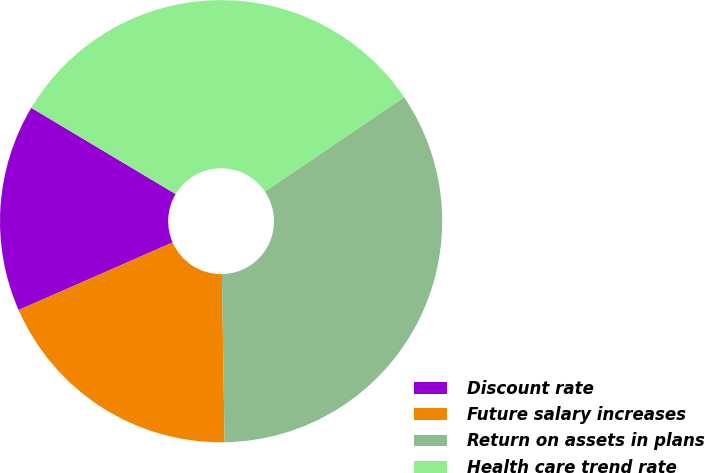Convert chart to OTSL. <chart><loc_0><loc_0><loc_500><loc_500><pie_chart><fcel>Discount rate<fcel>Future salary increases<fcel>Return on assets in plans<fcel>Health care trend rate<nl><fcel>15.15%<fcel>18.67%<fcel>34.23%<fcel>31.95%<nl></chart> 